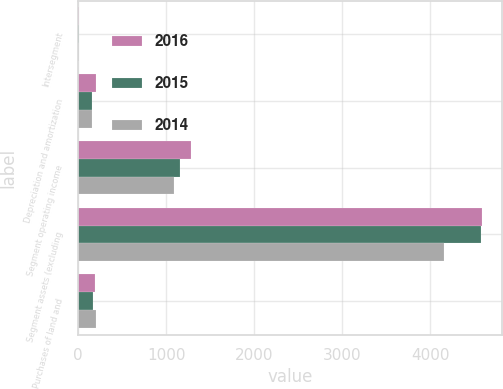Convert chart to OTSL. <chart><loc_0><loc_0><loc_500><loc_500><stacked_bar_chart><ecel><fcel>Intersegment<fcel>Depreciation and amortization<fcel>Segment operating income<fcel>Segment assets (excluding<fcel>Purchases of land and<nl><fcel>2016<fcel>6.9<fcel>206.8<fcel>1280.3<fcel>4587.5<fcel>186.2<nl><fcel>2015<fcel>7.2<fcel>162.3<fcel>1158.3<fcel>4580.4<fcel>167.1<nl><fcel>2014<fcel>6.6<fcel>160<fcel>1088<fcel>4161.7<fcel>203.1<nl></chart> 